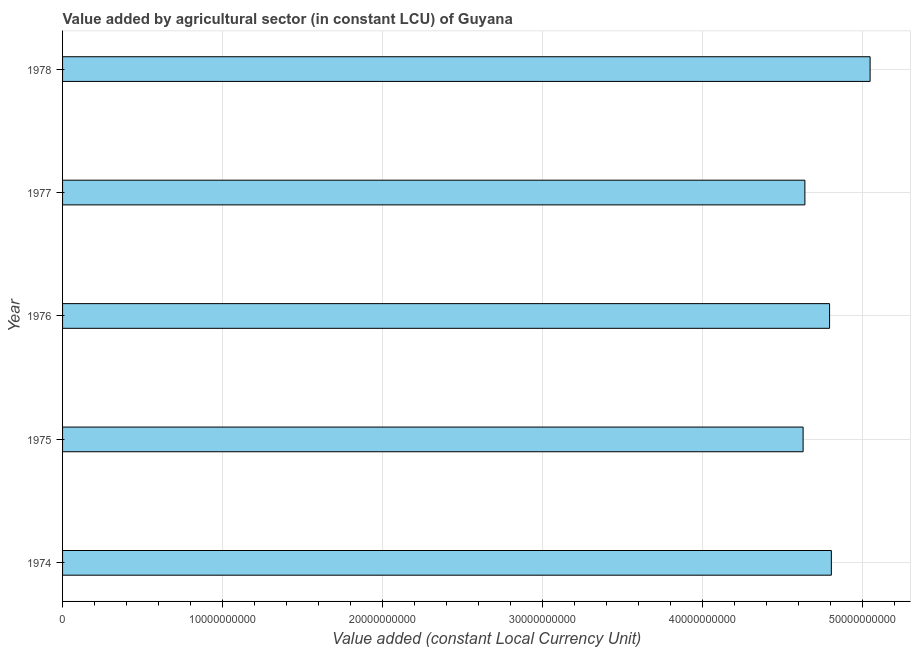Does the graph contain any zero values?
Keep it short and to the point. No. Does the graph contain grids?
Your response must be concise. Yes. What is the title of the graph?
Provide a short and direct response. Value added by agricultural sector (in constant LCU) of Guyana. What is the label or title of the X-axis?
Your answer should be compact. Value added (constant Local Currency Unit). What is the label or title of the Y-axis?
Provide a short and direct response. Year. What is the value added by agriculture sector in 1978?
Provide a succinct answer. 5.05e+1. Across all years, what is the maximum value added by agriculture sector?
Give a very brief answer. 5.05e+1. Across all years, what is the minimum value added by agriculture sector?
Offer a terse response. 4.63e+1. In which year was the value added by agriculture sector maximum?
Provide a short and direct response. 1978. In which year was the value added by agriculture sector minimum?
Provide a succinct answer. 1975. What is the sum of the value added by agriculture sector?
Offer a very short reply. 2.39e+11. What is the difference between the value added by agriculture sector in 1974 and 1978?
Give a very brief answer. -2.42e+09. What is the average value added by agriculture sector per year?
Your answer should be very brief. 4.78e+1. What is the median value added by agriculture sector?
Provide a succinct answer. 4.79e+1. Do a majority of the years between 1976 and 1978 (inclusive) have value added by agriculture sector greater than 34000000000 LCU?
Your response must be concise. Yes. What is the ratio of the value added by agriculture sector in 1974 to that in 1975?
Ensure brevity in your answer.  1.04. Is the value added by agriculture sector in 1974 less than that in 1976?
Your response must be concise. No. What is the difference between the highest and the second highest value added by agriculture sector?
Your response must be concise. 2.42e+09. What is the difference between the highest and the lowest value added by agriculture sector?
Your answer should be compact. 4.19e+09. In how many years, is the value added by agriculture sector greater than the average value added by agriculture sector taken over all years?
Keep it short and to the point. 3. How many bars are there?
Provide a succinct answer. 5. Are all the bars in the graph horizontal?
Give a very brief answer. Yes. What is the Value added (constant Local Currency Unit) of 1974?
Keep it short and to the point. 4.80e+1. What is the Value added (constant Local Currency Unit) in 1975?
Your answer should be very brief. 4.63e+1. What is the Value added (constant Local Currency Unit) in 1976?
Offer a very short reply. 4.79e+1. What is the Value added (constant Local Currency Unit) in 1977?
Your response must be concise. 4.64e+1. What is the Value added (constant Local Currency Unit) of 1978?
Provide a succinct answer. 5.05e+1. What is the difference between the Value added (constant Local Currency Unit) in 1974 and 1975?
Offer a terse response. 1.76e+09. What is the difference between the Value added (constant Local Currency Unit) in 1974 and 1976?
Your answer should be very brief. 1.11e+08. What is the difference between the Value added (constant Local Currency Unit) in 1974 and 1977?
Make the answer very short. 1.65e+09. What is the difference between the Value added (constant Local Currency Unit) in 1974 and 1978?
Make the answer very short. -2.42e+09. What is the difference between the Value added (constant Local Currency Unit) in 1975 and 1976?
Ensure brevity in your answer.  -1.65e+09. What is the difference between the Value added (constant Local Currency Unit) in 1975 and 1977?
Ensure brevity in your answer.  -1.11e+08. What is the difference between the Value added (constant Local Currency Unit) in 1975 and 1978?
Ensure brevity in your answer.  -4.19e+09. What is the difference between the Value added (constant Local Currency Unit) in 1976 and 1977?
Your response must be concise. 1.54e+09. What is the difference between the Value added (constant Local Currency Unit) in 1976 and 1978?
Make the answer very short. -2.53e+09. What is the difference between the Value added (constant Local Currency Unit) in 1977 and 1978?
Make the answer very short. -4.08e+09. What is the ratio of the Value added (constant Local Currency Unit) in 1974 to that in 1975?
Make the answer very short. 1.04. What is the ratio of the Value added (constant Local Currency Unit) in 1974 to that in 1977?
Ensure brevity in your answer.  1.04. What is the ratio of the Value added (constant Local Currency Unit) in 1975 to that in 1976?
Offer a terse response. 0.97. What is the ratio of the Value added (constant Local Currency Unit) in 1975 to that in 1977?
Your response must be concise. 1. What is the ratio of the Value added (constant Local Currency Unit) in 1975 to that in 1978?
Provide a succinct answer. 0.92. What is the ratio of the Value added (constant Local Currency Unit) in 1976 to that in 1977?
Keep it short and to the point. 1.03. What is the ratio of the Value added (constant Local Currency Unit) in 1976 to that in 1978?
Offer a very short reply. 0.95. What is the ratio of the Value added (constant Local Currency Unit) in 1977 to that in 1978?
Your response must be concise. 0.92. 